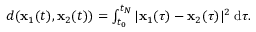<formula> <loc_0><loc_0><loc_500><loc_500>\begin{array} { r } { d ( { \mathbf x } _ { 1 } ( t ) , { \mathbf x } _ { 2 } ( t ) ) = \int _ { t _ { 0 } } ^ { t _ { N } } | { \mathbf x } _ { 1 } ( \tau ) - { \mathbf x } _ { 2 } ( \tau ) | ^ { 2 } \, d \tau . } \end{array}</formula> 